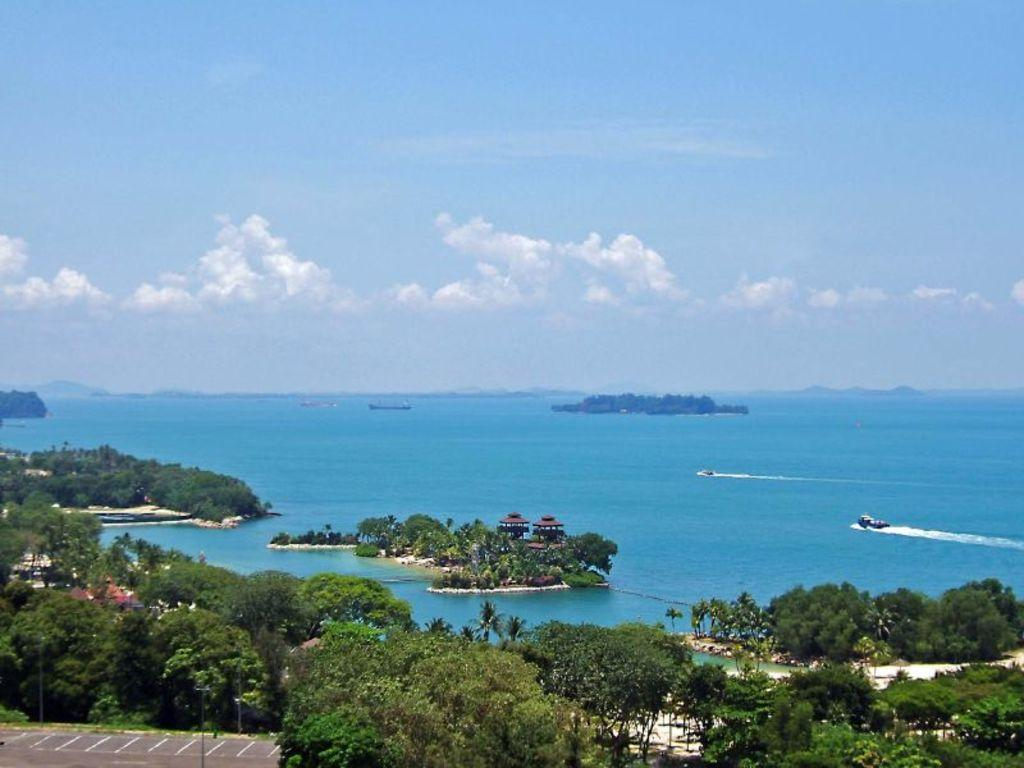What type of vegetation can be seen in the image? There are trees in the image. What type of street furniture is present in the image? There are lamp posts in the image. What type of area is depicted in the image? There is a parking lot in the image. What type of buildings can be seen in the image? There are houses in the image. What type of geographical features can be seen in the water in the image? There are islands in the water in the image. What type of vehicles can be seen in the sea in the image? There are boats in the sea in the image. What type of weather can be inferred from the image? There are clouds in the sky at the top of the image, suggesting a partly cloudy day. Where is the fireman located in the image? There is no fireman present in the image. What type of animal is seen playing with the pig in the image? There is no pig or animal present in the image. 